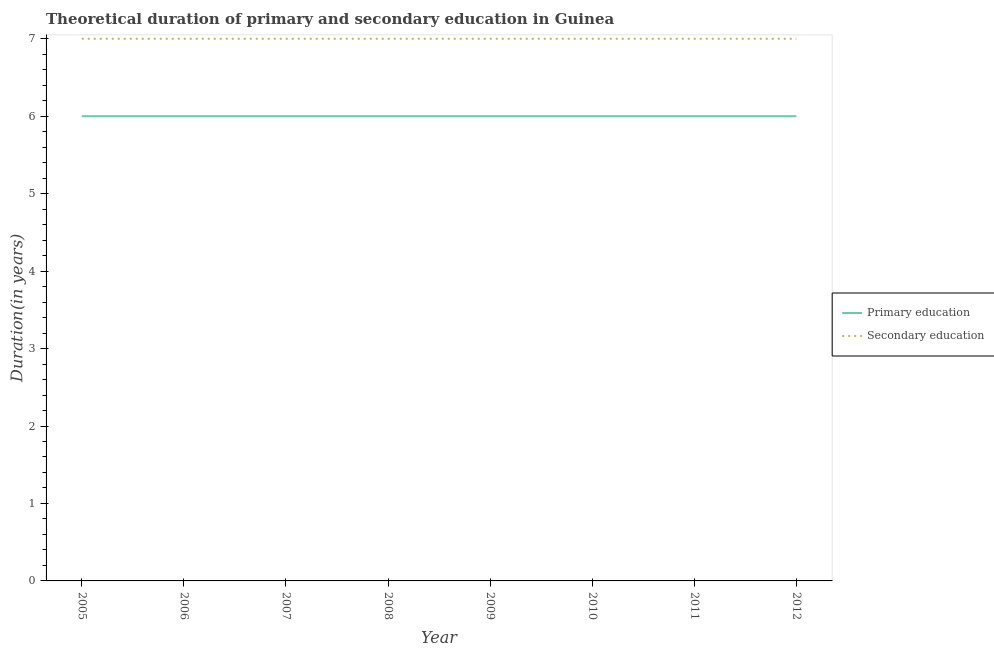Does the line corresponding to duration of secondary education intersect with the line corresponding to duration of primary education?
Make the answer very short. No. Is the number of lines equal to the number of legend labels?
Make the answer very short. Yes. What is the duration of secondary education in 2005?
Offer a very short reply. 7. What is the total duration of secondary education in the graph?
Keep it short and to the point. 56. What is the difference between the duration of secondary education in 2005 and that in 2011?
Make the answer very short. 0. What is the difference between the duration of secondary education in 2006 and the duration of primary education in 2012?
Make the answer very short. 1. What is the average duration of primary education per year?
Your response must be concise. 6. In the year 2006, what is the difference between the duration of secondary education and duration of primary education?
Provide a short and direct response. 1. What is the difference between the highest and the lowest duration of secondary education?
Provide a succinct answer. 0. In how many years, is the duration of secondary education greater than the average duration of secondary education taken over all years?
Your answer should be compact. 0. Is the sum of the duration of primary education in 2008 and 2010 greater than the maximum duration of secondary education across all years?
Provide a succinct answer. Yes. Does the duration of primary education monotonically increase over the years?
Your response must be concise. No. Is the duration of secondary education strictly less than the duration of primary education over the years?
Offer a terse response. No. How many lines are there?
Give a very brief answer. 2. Does the graph contain any zero values?
Ensure brevity in your answer.  No. Does the graph contain grids?
Give a very brief answer. No. How are the legend labels stacked?
Give a very brief answer. Vertical. What is the title of the graph?
Offer a very short reply. Theoretical duration of primary and secondary education in Guinea. What is the label or title of the X-axis?
Make the answer very short. Year. What is the label or title of the Y-axis?
Provide a succinct answer. Duration(in years). What is the Duration(in years) in Secondary education in 2005?
Your answer should be compact. 7. What is the Duration(in years) of Primary education in 2008?
Give a very brief answer. 6. What is the Duration(in years) in Secondary education in 2008?
Make the answer very short. 7. What is the Duration(in years) of Secondary education in 2010?
Provide a short and direct response. 7. What is the Duration(in years) in Primary education in 2011?
Ensure brevity in your answer.  6. What is the Duration(in years) of Secondary education in 2011?
Offer a terse response. 7. What is the Duration(in years) in Primary education in 2012?
Your response must be concise. 6. Across all years, what is the maximum Duration(in years) in Primary education?
Offer a very short reply. 6. Across all years, what is the maximum Duration(in years) of Secondary education?
Your answer should be compact. 7. What is the total Duration(in years) in Secondary education in the graph?
Ensure brevity in your answer.  56. What is the difference between the Duration(in years) in Primary education in 2005 and that in 2006?
Ensure brevity in your answer.  0. What is the difference between the Duration(in years) of Secondary education in 2005 and that in 2008?
Your answer should be very brief. 0. What is the difference between the Duration(in years) of Primary education in 2005 and that in 2009?
Your answer should be compact. 0. What is the difference between the Duration(in years) of Primary education in 2005 and that in 2010?
Offer a terse response. 0. What is the difference between the Duration(in years) in Secondary education in 2005 and that in 2010?
Give a very brief answer. 0. What is the difference between the Duration(in years) of Primary education in 2005 and that in 2011?
Provide a succinct answer. 0. What is the difference between the Duration(in years) of Secondary education in 2005 and that in 2012?
Your answer should be very brief. 0. What is the difference between the Duration(in years) of Primary education in 2006 and that in 2009?
Your response must be concise. 0. What is the difference between the Duration(in years) of Primary education in 2006 and that in 2011?
Keep it short and to the point. 0. What is the difference between the Duration(in years) in Secondary education in 2006 and that in 2011?
Offer a very short reply. 0. What is the difference between the Duration(in years) of Primary education in 2006 and that in 2012?
Your answer should be compact. 0. What is the difference between the Duration(in years) of Primary education in 2007 and that in 2008?
Your answer should be compact. 0. What is the difference between the Duration(in years) of Secondary education in 2007 and that in 2008?
Your answer should be compact. 0. What is the difference between the Duration(in years) of Primary education in 2007 and that in 2009?
Your response must be concise. 0. What is the difference between the Duration(in years) in Primary education in 2007 and that in 2011?
Your answer should be very brief. 0. What is the difference between the Duration(in years) in Primary education in 2007 and that in 2012?
Your answer should be very brief. 0. What is the difference between the Duration(in years) in Secondary education in 2007 and that in 2012?
Offer a very short reply. 0. What is the difference between the Duration(in years) in Primary education in 2008 and that in 2009?
Offer a terse response. 0. What is the difference between the Duration(in years) of Primary education in 2008 and that in 2012?
Your answer should be compact. 0. What is the difference between the Duration(in years) in Secondary education in 2009 and that in 2010?
Make the answer very short. 0. What is the difference between the Duration(in years) of Primary education in 2009 and that in 2011?
Your answer should be compact. 0. What is the difference between the Duration(in years) in Secondary education in 2009 and that in 2011?
Your answer should be compact. 0. What is the difference between the Duration(in years) in Primary education in 2009 and that in 2012?
Provide a succinct answer. 0. What is the difference between the Duration(in years) of Primary education in 2010 and that in 2011?
Your answer should be very brief. 0. What is the difference between the Duration(in years) of Primary education in 2010 and that in 2012?
Provide a short and direct response. 0. What is the difference between the Duration(in years) in Secondary education in 2010 and that in 2012?
Provide a short and direct response. 0. What is the difference between the Duration(in years) of Primary education in 2011 and that in 2012?
Your answer should be very brief. 0. What is the difference between the Duration(in years) of Secondary education in 2011 and that in 2012?
Your answer should be compact. 0. What is the difference between the Duration(in years) in Primary education in 2005 and the Duration(in years) in Secondary education in 2010?
Offer a very short reply. -1. What is the difference between the Duration(in years) in Primary education in 2005 and the Duration(in years) in Secondary education in 2011?
Make the answer very short. -1. What is the difference between the Duration(in years) in Primary education in 2005 and the Duration(in years) in Secondary education in 2012?
Make the answer very short. -1. What is the difference between the Duration(in years) of Primary education in 2006 and the Duration(in years) of Secondary education in 2009?
Keep it short and to the point. -1. What is the difference between the Duration(in years) in Primary education in 2006 and the Duration(in years) in Secondary education in 2012?
Provide a short and direct response. -1. What is the difference between the Duration(in years) of Primary education in 2007 and the Duration(in years) of Secondary education in 2010?
Offer a terse response. -1. What is the difference between the Duration(in years) in Primary education in 2008 and the Duration(in years) in Secondary education in 2009?
Keep it short and to the point. -1. What is the difference between the Duration(in years) in Primary education in 2008 and the Duration(in years) in Secondary education in 2010?
Provide a short and direct response. -1. What is the difference between the Duration(in years) of Primary education in 2009 and the Duration(in years) of Secondary education in 2010?
Make the answer very short. -1. What is the difference between the Duration(in years) in Primary education in 2009 and the Duration(in years) in Secondary education in 2011?
Keep it short and to the point. -1. What is the difference between the Duration(in years) in Primary education in 2009 and the Duration(in years) in Secondary education in 2012?
Your answer should be compact. -1. What is the difference between the Duration(in years) of Primary education in 2010 and the Duration(in years) of Secondary education in 2012?
Provide a short and direct response. -1. What is the difference between the Duration(in years) of Primary education in 2011 and the Duration(in years) of Secondary education in 2012?
Your answer should be very brief. -1. What is the average Duration(in years) in Primary education per year?
Ensure brevity in your answer.  6. In the year 2006, what is the difference between the Duration(in years) of Primary education and Duration(in years) of Secondary education?
Your answer should be very brief. -1. In the year 2007, what is the difference between the Duration(in years) in Primary education and Duration(in years) in Secondary education?
Provide a succinct answer. -1. In the year 2009, what is the difference between the Duration(in years) in Primary education and Duration(in years) in Secondary education?
Offer a terse response. -1. In the year 2011, what is the difference between the Duration(in years) of Primary education and Duration(in years) of Secondary education?
Offer a terse response. -1. What is the ratio of the Duration(in years) of Primary education in 2005 to that in 2006?
Provide a short and direct response. 1. What is the ratio of the Duration(in years) in Primary education in 2005 to that in 2007?
Give a very brief answer. 1. What is the ratio of the Duration(in years) of Primary education in 2005 to that in 2008?
Offer a terse response. 1. What is the ratio of the Duration(in years) of Secondary education in 2005 to that in 2008?
Your answer should be compact. 1. What is the ratio of the Duration(in years) in Primary education in 2005 to that in 2009?
Your answer should be compact. 1. What is the ratio of the Duration(in years) in Primary education in 2005 to that in 2010?
Your answer should be compact. 1. What is the ratio of the Duration(in years) of Secondary education in 2005 to that in 2011?
Make the answer very short. 1. What is the ratio of the Duration(in years) of Primary education in 2005 to that in 2012?
Ensure brevity in your answer.  1. What is the ratio of the Duration(in years) in Secondary education in 2005 to that in 2012?
Ensure brevity in your answer.  1. What is the ratio of the Duration(in years) of Primary education in 2006 to that in 2007?
Your answer should be compact. 1. What is the ratio of the Duration(in years) in Primary education in 2006 to that in 2008?
Your answer should be very brief. 1. What is the ratio of the Duration(in years) in Secondary education in 2006 to that in 2008?
Provide a short and direct response. 1. What is the ratio of the Duration(in years) of Secondary education in 2006 to that in 2010?
Keep it short and to the point. 1. What is the ratio of the Duration(in years) of Primary education in 2006 to that in 2011?
Your answer should be very brief. 1. What is the ratio of the Duration(in years) of Secondary education in 2006 to that in 2011?
Offer a terse response. 1. What is the ratio of the Duration(in years) in Secondary education in 2007 to that in 2008?
Your response must be concise. 1. What is the ratio of the Duration(in years) in Primary education in 2007 to that in 2010?
Your response must be concise. 1. What is the ratio of the Duration(in years) of Secondary education in 2007 to that in 2010?
Keep it short and to the point. 1. What is the ratio of the Duration(in years) in Primary education in 2007 to that in 2011?
Offer a terse response. 1. What is the ratio of the Duration(in years) of Primary education in 2007 to that in 2012?
Give a very brief answer. 1. What is the ratio of the Duration(in years) of Primary education in 2008 to that in 2009?
Your answer should be very brief. 1. What is the ratio of the Duration(in years) of Secondary education in 2008 to that in 2009?
Provide a succinct answer. 1. What is the ratio of the Duration(in years) in Primary education in 2008 to that in 2011?
Provide a succinct answer. 1. What is the ratio of the Duration(in years) of Secondary education in 2008 to that in 2012?
Keep it short and to the point. 1. What is the ratio of the Duration(in years) of Secondary education in 2009 to that in 2011?
Your response must be concise. 1. What is the ratio of the Duration(in years) of Primary education in 2009 to that in 2012?
Keep it short and to the point. 1. What is the ratio of the Duration(in years) of Secondary education in 2010 to that in 2011?
Your response must be concise. 1. What is the ratio of the Duration(in years) of Primary education in 2010 to that in 2012?
Offer a terse response. 1. What is the ratio of the Duration(in years) in Secondary education in 2010 to that in 2012?
Give a very brief answer. 1. What is the ratio of the Duration(in years) in Primary education in 2011 to that in 2012?
Your response must be concise. 1. What is the ratio of the Duration(in years) in Secondary education in 2011 to that in 2012?
Offer a terse response. 1. What is the difference between the highest and the second highest Duration(in years) in Secondary education?
Keep it short and to the point. 0. What is the difference between the highest and the lowest Duration(in years) in Primary education?
Give a very brief answer. 0. What is the difference between the highest and the lowest Duration(in years) of Secondary education?
Keep it short and to the point. 0. 